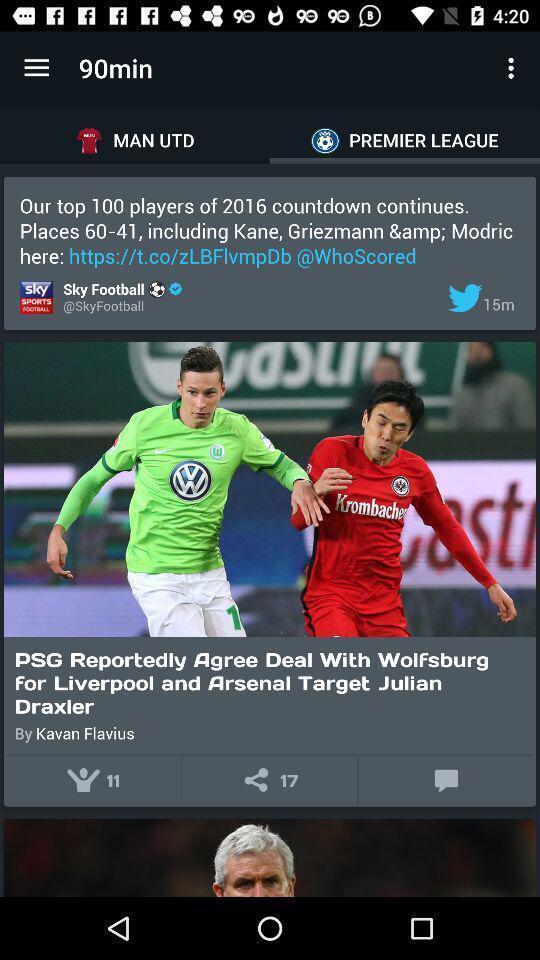Summarize the information in this screenshot. Screen displaying the news articles in premier league tab. 